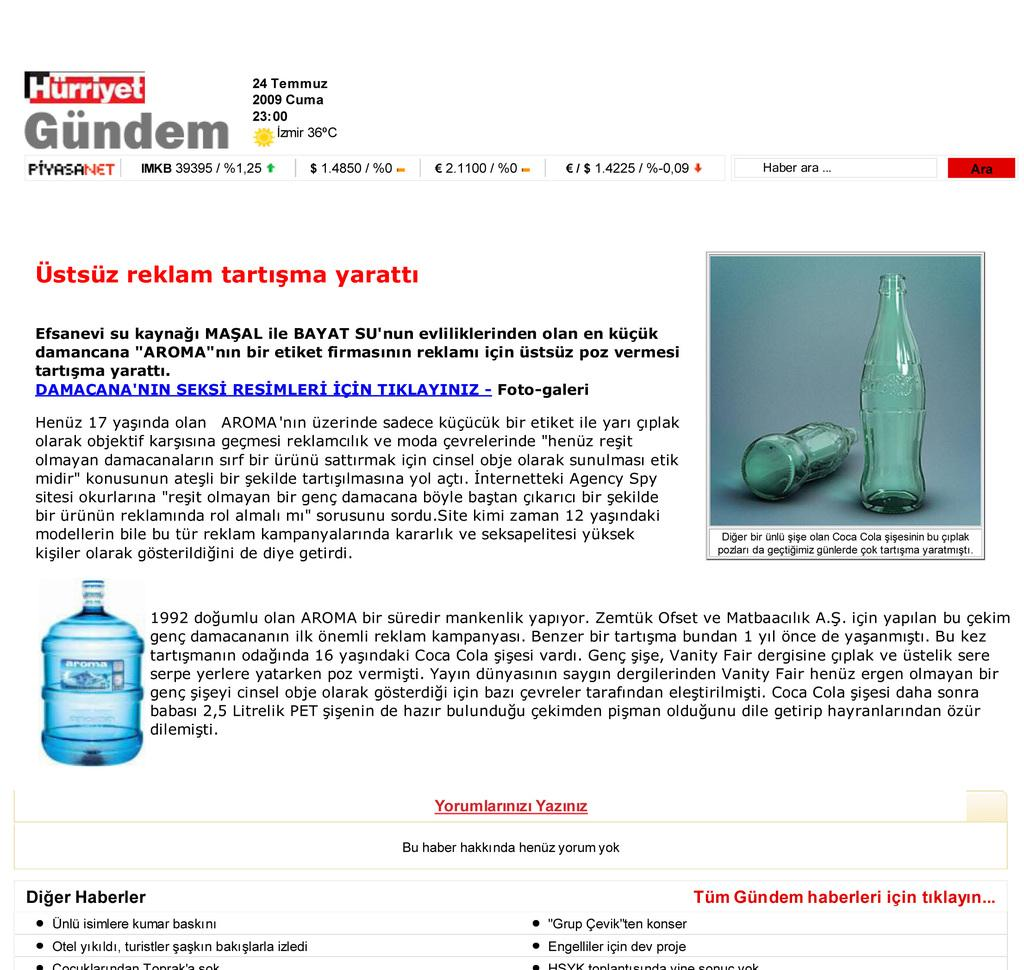<image>
Describe the image concisely. A web page with bottles shown has Gundem on the left upper corner of the page. 